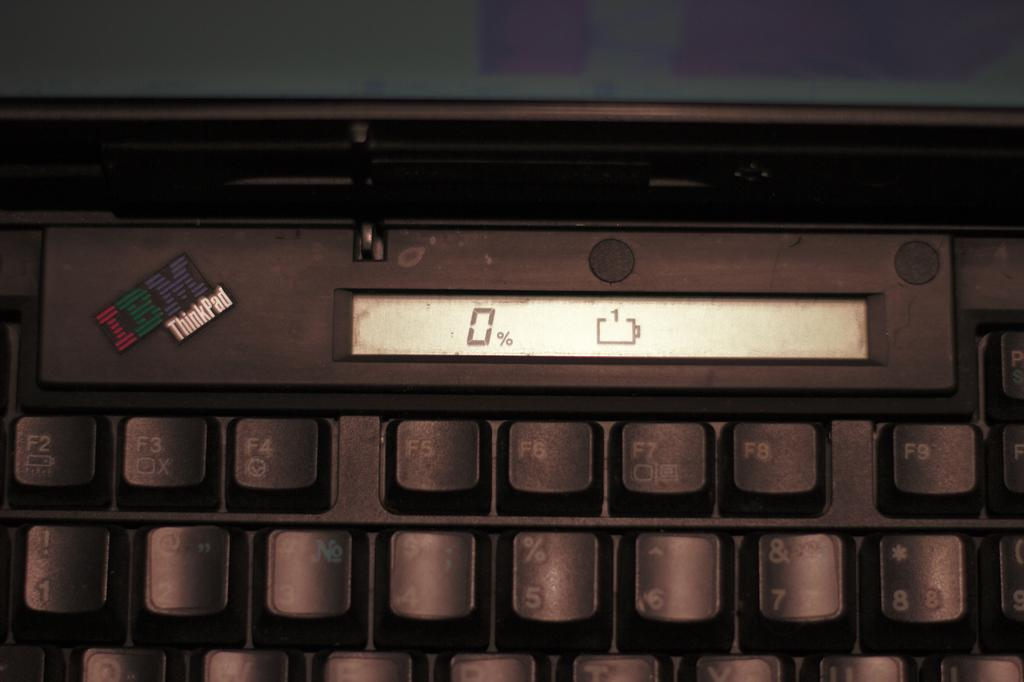<image>
Summarize the visual content of the image. the number 0 is on the sign above some keys 